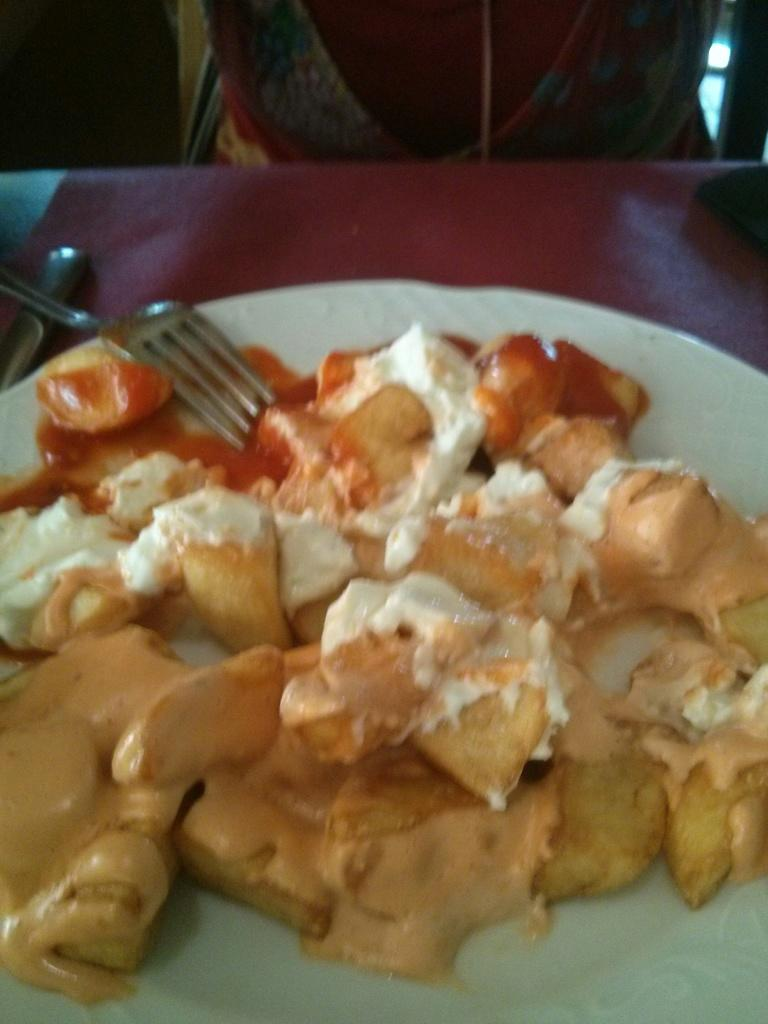What is on the plate that is visible in the image? There is a plate with food in the image. What utensil is present in the image? There is a fork in the image. What else can be seen on the table in the image? There is an object on the table in the image. How many frogs are sitting on the plate in the image? There are no frogs present in the image; it features a plate with food and a fork. What type of honey can be seen drizzled over the food in the image? There is no honey present in the image; it only shows a plate with food and a fork. 